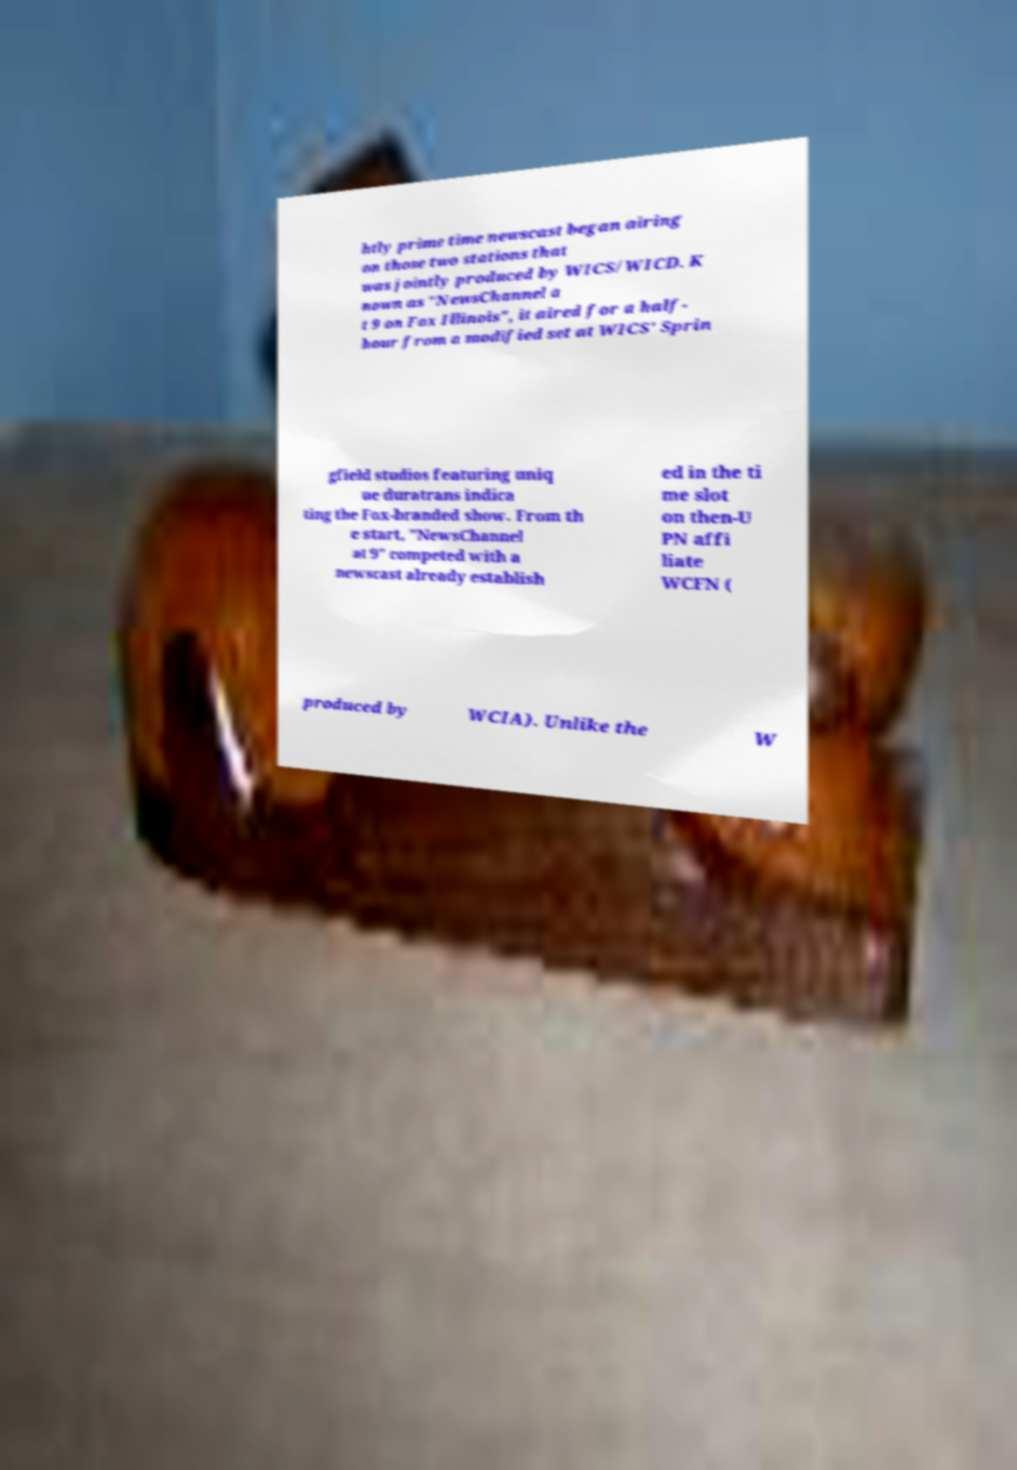Could you extract and type out the text from this image? htly prime time newscast began airing on those two stations that was jointly produced by WICS/WICD. K nown as "NewsChannel a t 9 on Fox Illinois", it aired for a half- hour from a modified set at WICS' Sprin gfield studios featuring uniq ue duratrans indica ting the Fox-branded show. From th e start, "NewsChannel at 9" competed with a newscast already establish ed in the ti me slot on then-U PN affi liate WCFN ( produced by WCIA). Unlike the W 